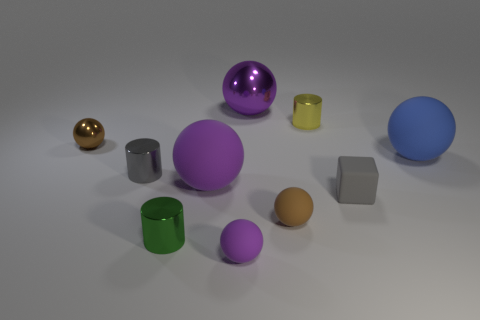Subtract all small gray cylinders. How many cylinders are left? 2 Subtract all brown cubes. How many purple spheres are left? 3 Subtract all blue balls. How many balls are left? 5 Subtract all cylinders. How many objects are left? 7 Subtract 1 spheres. How many spheres are left? 5 Add 2 gray cylinders. How many gray cylinders are left? 3 Add 4 green rubber cylinders. How many green rubber cylinders exist? 4 Subtract 1 gray cylinders. How many objects are left? 9 Subtract all green balls. Subtract all brown cubes. How many balls are left? 6 Subtract all small gray cylinders. Subtract all tiny brown shiny objects. How many objects are left? 8 